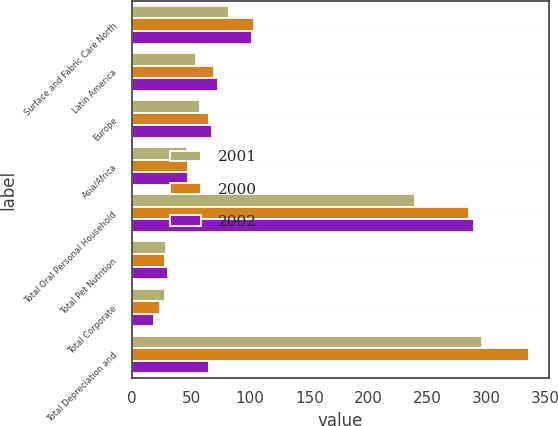Convert chart to OTSL. <chart><loc_0><loc_0><loc_500><loc_500><stacked_bar_chart><ecel><fcel>Surface and Fabric Care North<fcel>Latin America<fcel>Europe<fcel>Asia/Africa<fcel>Total Oral Personal Household<fcel>Total Pet Nutrition<fcel>Total Corporate<fcel>Total Depreciation and<nl><fcel>2001<fcel>82.1<fcel>53.8<fcel>57.3<fcel>46.3<fcel>239.5<fcel>28.7<fcel>28.3<fcel>296.5<nl><fcel>2000<fcel>102.8<fcel>69.3<fcel>64.9<fcel>47.8<fcel>284.8<fcel>28.1<fcel>23.3<fcel>336.2<nl><fcel>2002<fcel>101.2<fcel>73<fcel>67.8<fcel>47<fcel>289<fcel>30.6<fcel>18.2<fcel>64.9<nl></chart> 